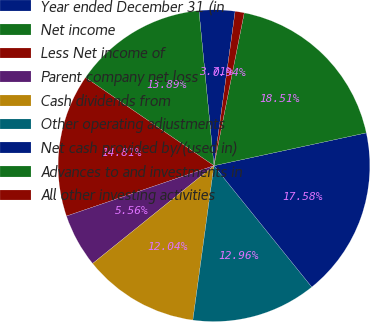Convert chart to OTSL. <chart><loc_0><loc_0><loc_500><loc_500><pie_chart><fcel>Year ended December 31 (in<fcel>Net income<fcel>Less Net income of<fcel>Parent company net loss<fcel>Cash dividends from<fcel>Other operating adjustments<fcel>Net cash provided by/(used in)<fcel>Advances to and investments in<fcel>All other investing activities<nl><fcel>3.71%<fcel>13.89%<fcel>14.81%<fcel>5.56%<fcel>12.04%<fcel>12.96%<fcel>17.58%<fcel>18.51%<fcel>0.94%<nl></chart> 